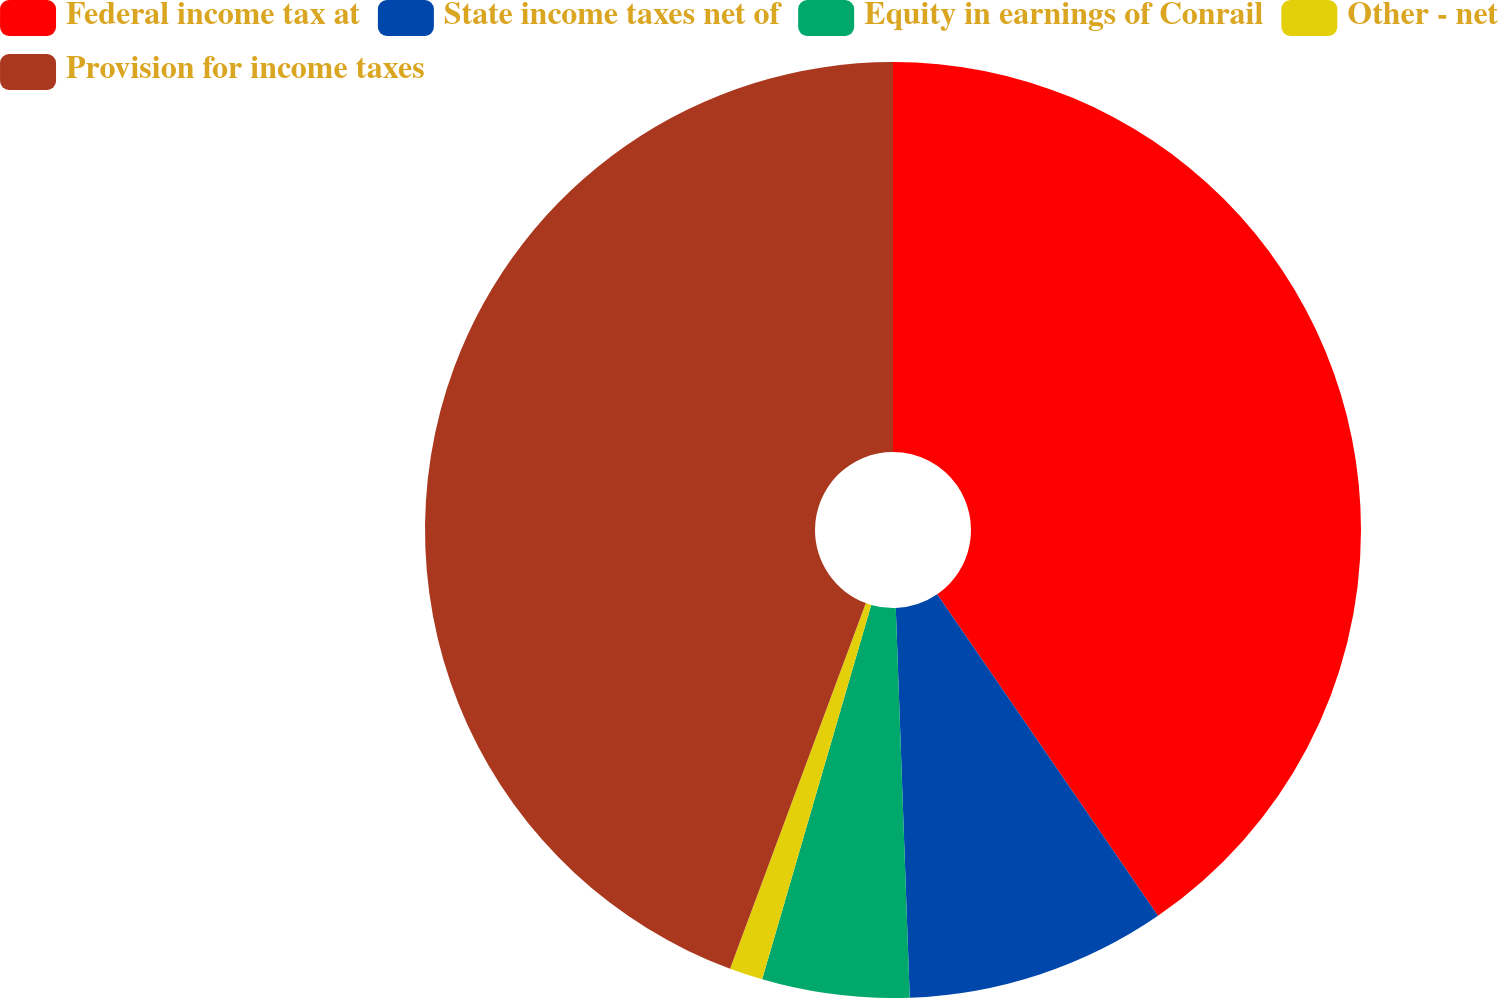<chart> <loc_0><loc_0><loc_500><loc_500><pie_chart><fcel>Federal income tax at<fcel>State income taxes net of<fcel>Equity in earnings of Conrail<fcel>Other - net<fcel>Provision for income taxes<nl><fcel>40.42%<fcel>9.01%<fcel>5.08%<fcel>1.15%<fcel>44.34%<nl></chart> 